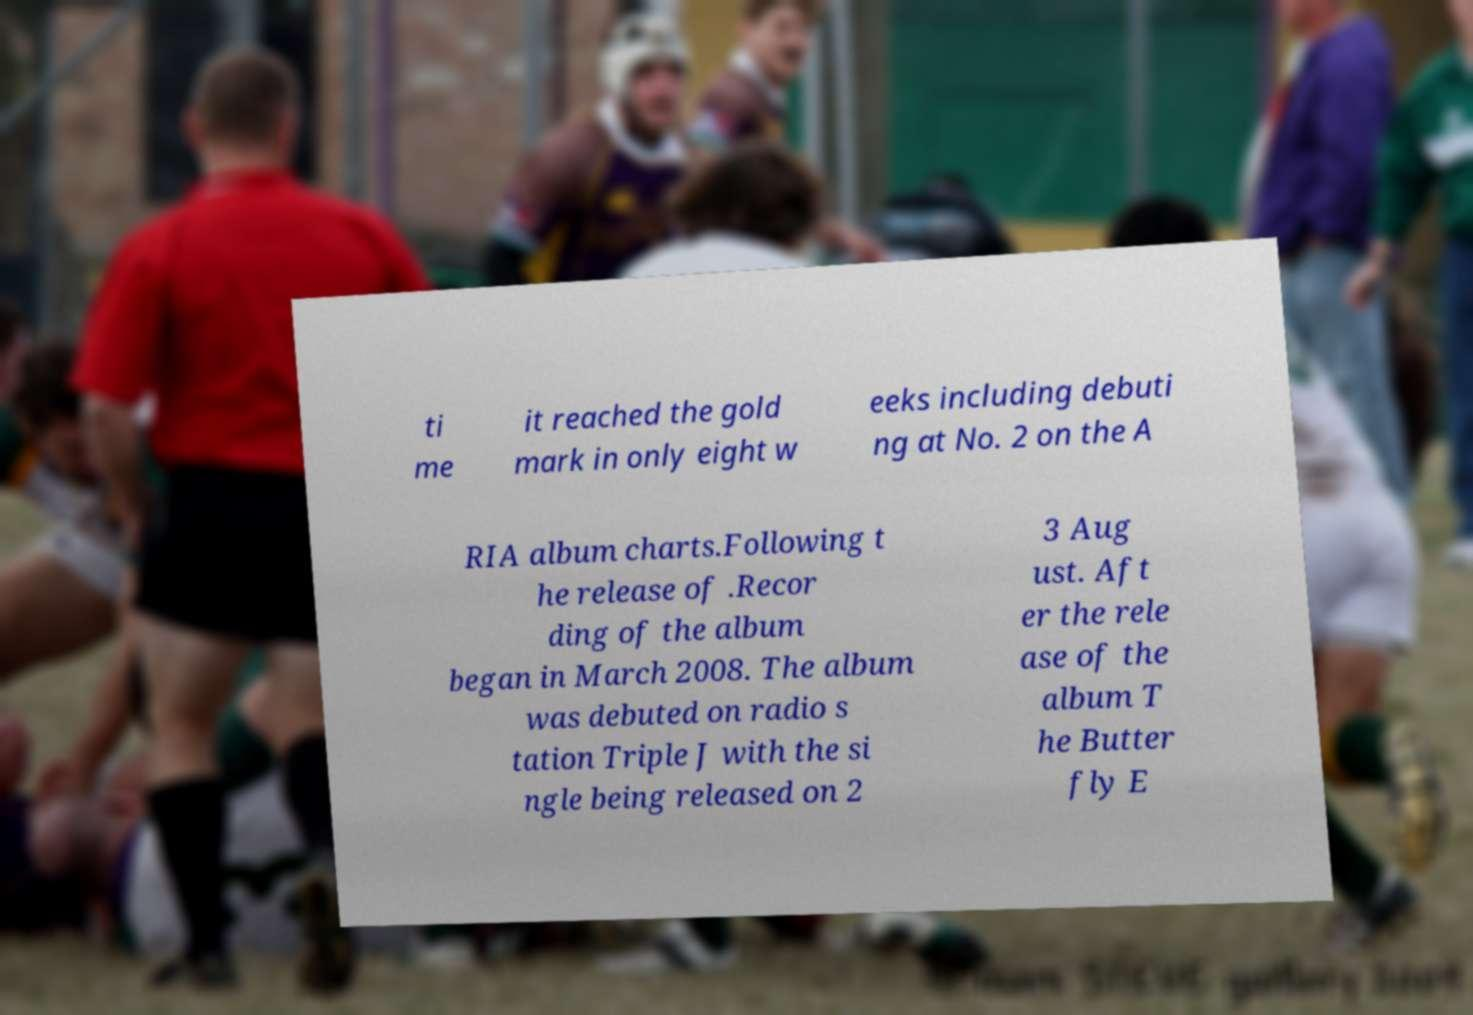Please identify and transcribe the text found in this image. ti me it reached the gold mark in only eight w eeks including debuti ng at No. 2 on the A RIA album charts.Following t he release of .Recor ding of the album began in March 2008. The album was debuted on radio s tation Triple J with the si ngle being released on 2 3 Aug ust. Aft er the rele ase of the album T he Butter fly E 